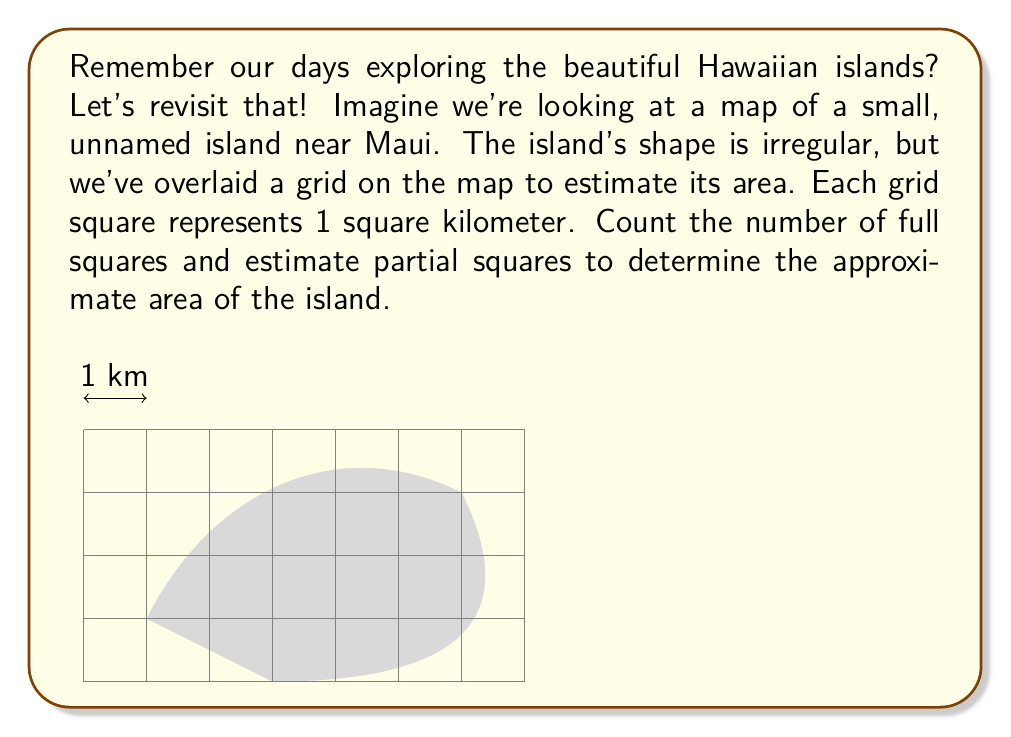Can you solve this math problem? To estimate the area of the irregular island shape, we'll follow these steps:

1. Count full squares: There are 12 complete squares within the island's boundaries.

2. Estimate partial squares:
   - Top row: approximately 0.5 + 0.75 + 0.5 = 1.75 squares
   - Bottom row: approximately 0.5 + 0.5 = 1 square
   - Left side: approximately 0.25 square
   - Right side: approximately 0.5 square

3. Sum up the estimates:
   $$ \text{Total squares} = 12 + 1.75 + 1 + 0.25 + 0.5 = 15.5 $$

4. Since each square represents 1 square kilometer, the estimated area is 15.5 square kilometers.

This method provides a reasonable estimate for irregular shapes using a grid overlay, which is a common technique in visual-spatial intelligence tests and geographical area estimations.
Answer: 15.5 km² 